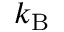<formula> <loc_0><loc_0><loc_500><loc_500>k _ { B }</formula> 